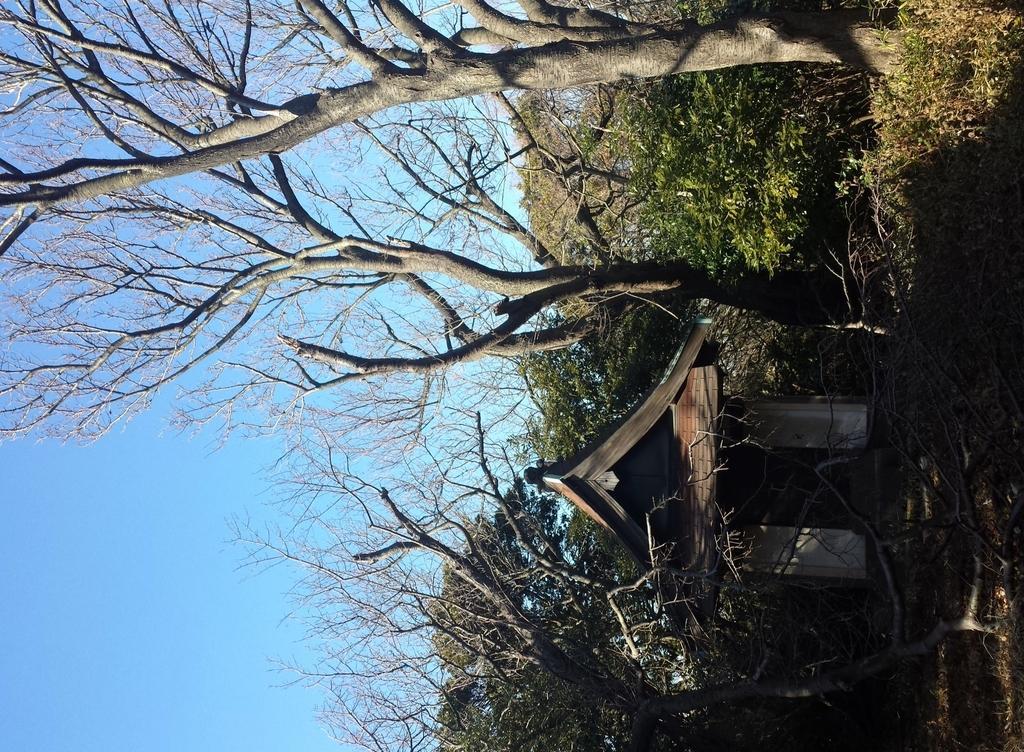Describe this image in one or two sentences. In this picture, it looks like a hut. Behind the hut, there are trees and the sky. At the top right corner of the image, there are plants. 